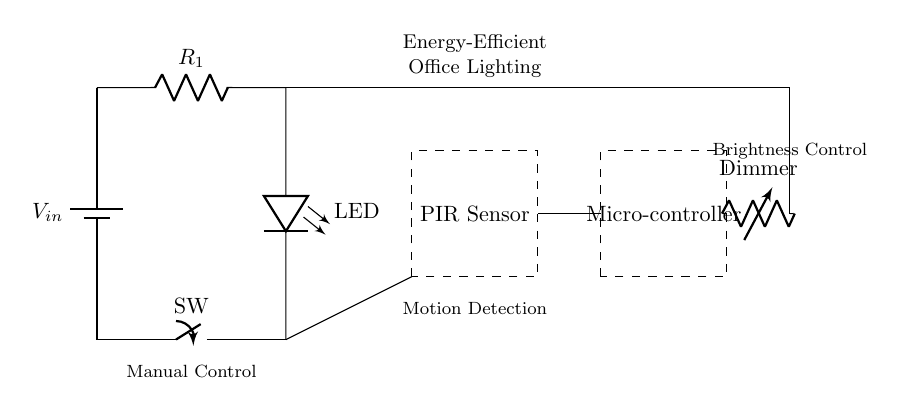What is the component used to limit the current? The component that limits the current in the circuit is the resistor labeled "R1." Resistors are used in circuits to control the flow of current by introducing resistance.
Answer: R1 What type of sensor is shown in the diagram? The diagram features a PIR (Passive Infrared) sensor, indicated within a dashed rectangle labeled "PIR Sensor." This component detects motion through changes in infrared radiation, which is utilized for energy-efficient lighting.
Answer: PIR Sensor How is brightness controlled in this circuit? Brightness is controlled through a dimmer labeled "Dimmer" in the circuit. The dimmer allows for adjustments in the light output from the LED, facilitating energy efficiency depending on the required illumination level.
Answer: Dimmer What is the function of the switch in the circuit? The switch, labeled "SW," serves as a manual control mechanism, enabling users to turn the LED light on or off. This direct interaction allows for user input in managing energy consumption.
Answer: Manual Control What does the microcontroller do in this circuit? The microcontroller, shown within a dashed rectangle, is responsible for processing input signals (like those from the PIR sensor) and controlling other components such as the LED and dimmer based on programmed logic.
Answer: Processing Control How does the PIR sensor contribute to energy efficiency? The PIR sensor detects motion and can turn the LED light on only when movement is sensed. Thus, it contributes to energy efficiency by ensuring that lights are activated only when there are occupants in the space, reducing unnecessary power consumption.
Answer: Motion Detection What is the purpose of the LED in the diagram? The LED (Light Emitting Diode) is utilized as the primary light source in the circuit. It is energy-efficient and provides illumination while consuming less power compared to traditional light sources.
Answer: LED 